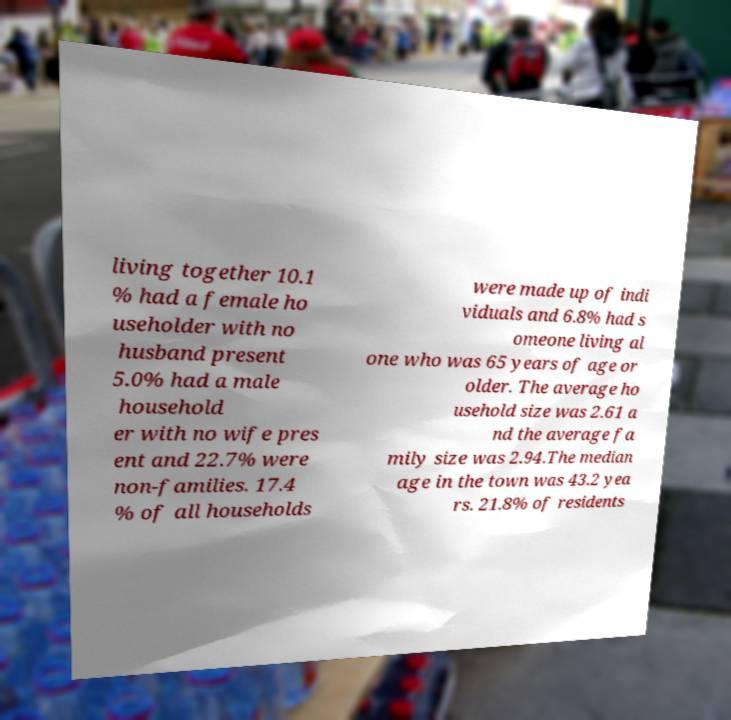I need the written content from this picture converted into text. Can you do that? living together 10.1 % had a female ho useholder with no husband present 5.0% had a male household er with no wife pres ent and 22.7% were non-families. 17.4 % of all households were made up of indi viduals and 6.8% had s omeone living al one who was 65 years of age or older. The average ho usehold size was 2.61 a nd the average fa mily size was 2.94.The median age in the town was 43.2 yea rs. 21.8% of residents 